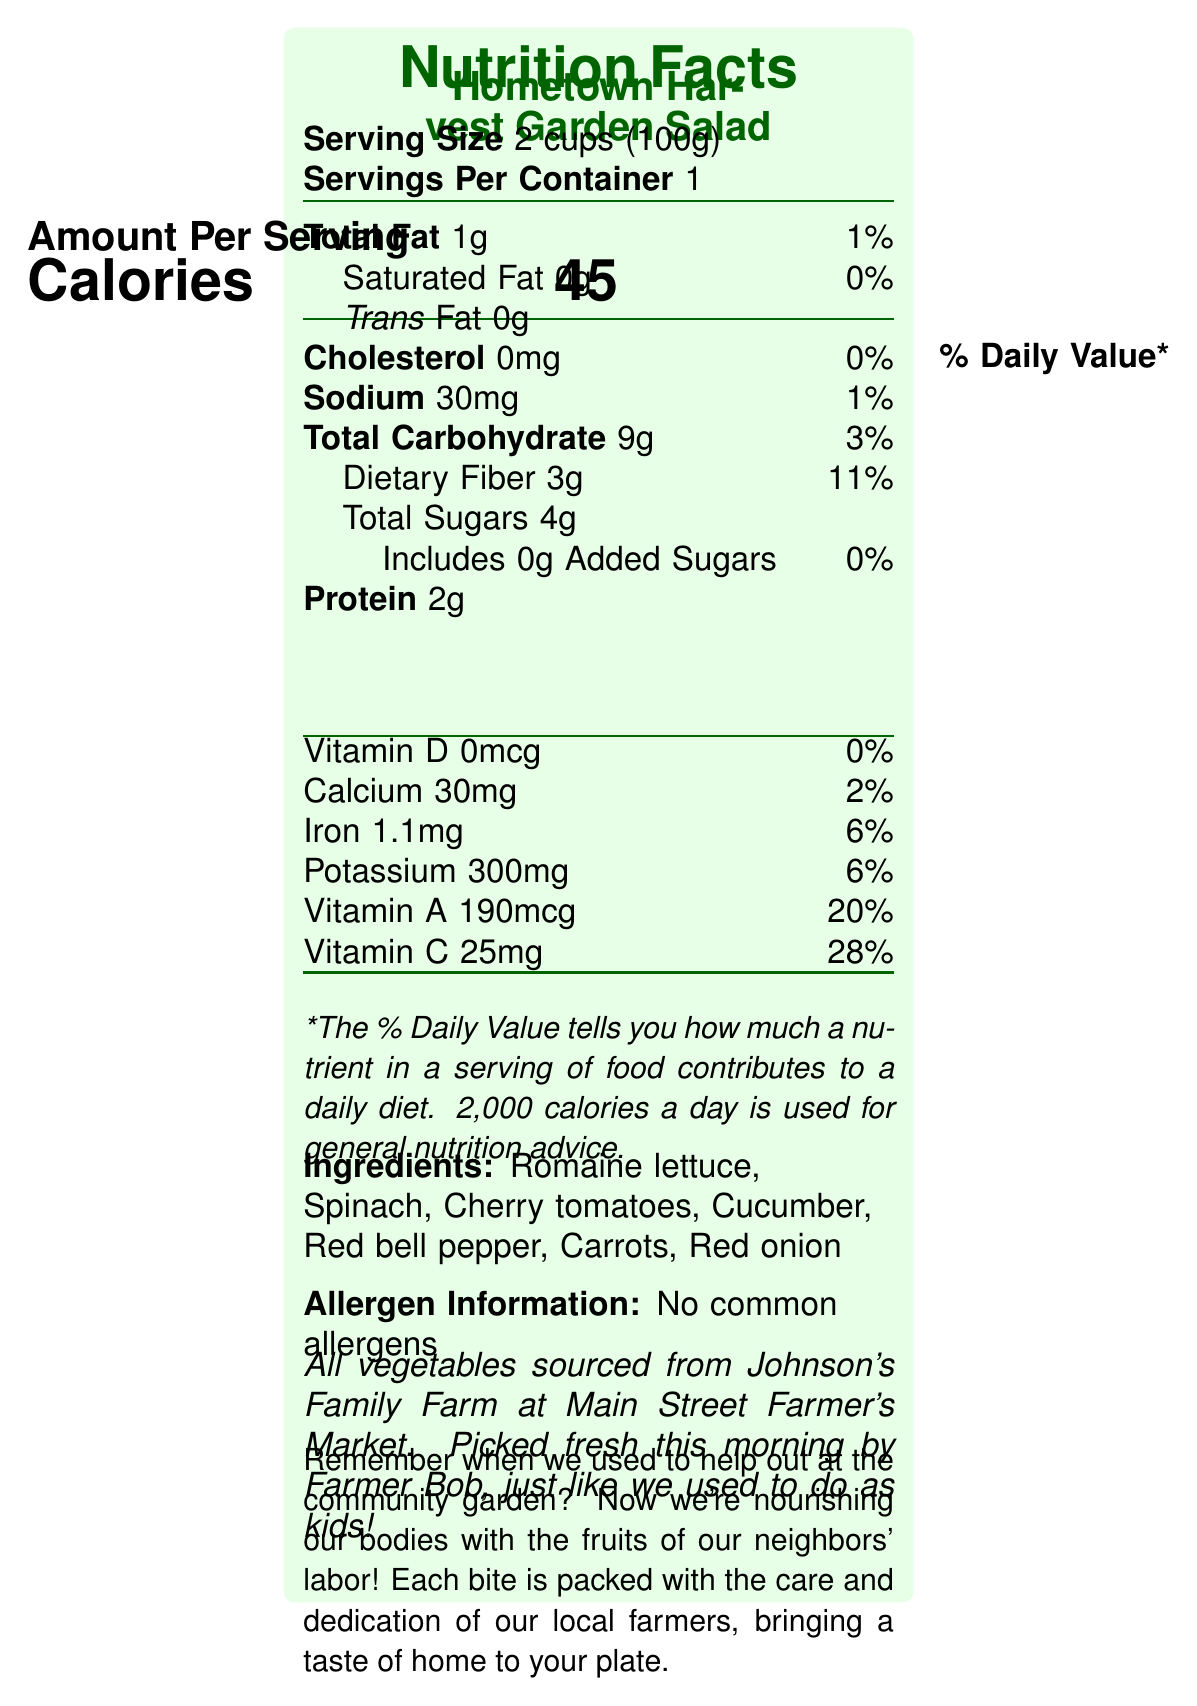who picked the vegetables for the Hometown Harvest Garden Salad? The document notes that "Picked fresh this morning by Farmer Bob, just like we used to do as kids!"
Answer: Farmer Bob how many grams of dietary fiber are in one serving of the salad? The Nutrition Facts section lists dietary fiber at 3g per serving.
Answer: 3 grams what is the serving size of the Hometown Harvest Garden Salad? The serving size is stated as "2 cups (100g)" in the document.
Answer: 2 cups (100g) how many calories are there per serving of the garden salad? The document states that there are 45 calories per serving.
Answer: 45 calories what is the sodium content in one serving of the garden salad? The document lists the sodium content as 30mg per serving.
Answer: 30mg which of the following ingredients are included in the Hometown Harvest Garden Salad? A. Kale B. Spinach C. Broccoli D. Zucchini Spinach is mentioned in the list of ingredients: "Romaine lettuce, Spinach, Cherry tomatoes, Cucumber, Red bell pepper, Carrots, Red onion."
Answer: B. Spinach which nutrient has the highest % Daily Value in the garden salad? A. Calcium B. Vitamin A C. Iron D. Vitamin C Vitamin C has the highest % Daily Value at 28% in the document.
Answer: D. Vitamin C are there any common allergens identified in this salad? The document clearly states: "Allergen Information: No common allergens."
Answer: No does the garden salad contain any added sugars? The document indicates "Includes 0g Added Sugars" with a daily value of 0%.
Answer: No summarize the main idea of the document. The document provides a detailed Nutrition Facts Label for the Hometown Harvest Garden Salad, listing its ingredients, nutritional content, preparation tips, and sustainability statement. It also emphasizes the local sourcing of ingredients and the importance of supporting community farmers.
Answer: The Hometown Harvest Garden Salad is a nutritious food product made with fresh vegetables from the local Johnson's Family Farm. It emphasizes the importance of supporting local growers, provides key nutritional information, and reminds consumers of their small-town roots. what is the main source of the vegetables in the salad? The document mentions that "All vegetables sourced from Johnson's Family Farm at Main Street Farmer's Market."
Answer: Johnson's Family Farm at Main Street Farmer's Market how should the vegetables in the garden salad be prepared for best flavor? The document advises, "Wash vegetables thoroughly before serving. For best flavor, enjoy within 2 days of purchase."
Answer: Wash thoroughly and enjoy within 2 days of purchase does the Hometown Harvest Garden Salad support sustainable farming practices? The sustainability statement says, "By choosing this salad, you're supporting sustainable farming practices and reducing food miles."
Answer: Yes what is the calcium content per serving? The document lists the calcium content as 30mg per serving.
Answer: 30mg did the community garden contribute to the ingredients of the garden salad? The document nostalgically mentions the community garden from childhood but does not state that it contributed to the ingredients of this specific salad.
Answer: Not enough information 